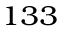<formula> <loc_0><loc_0><loc_500><loc_500>^ { 1 3 3 }</formula> 